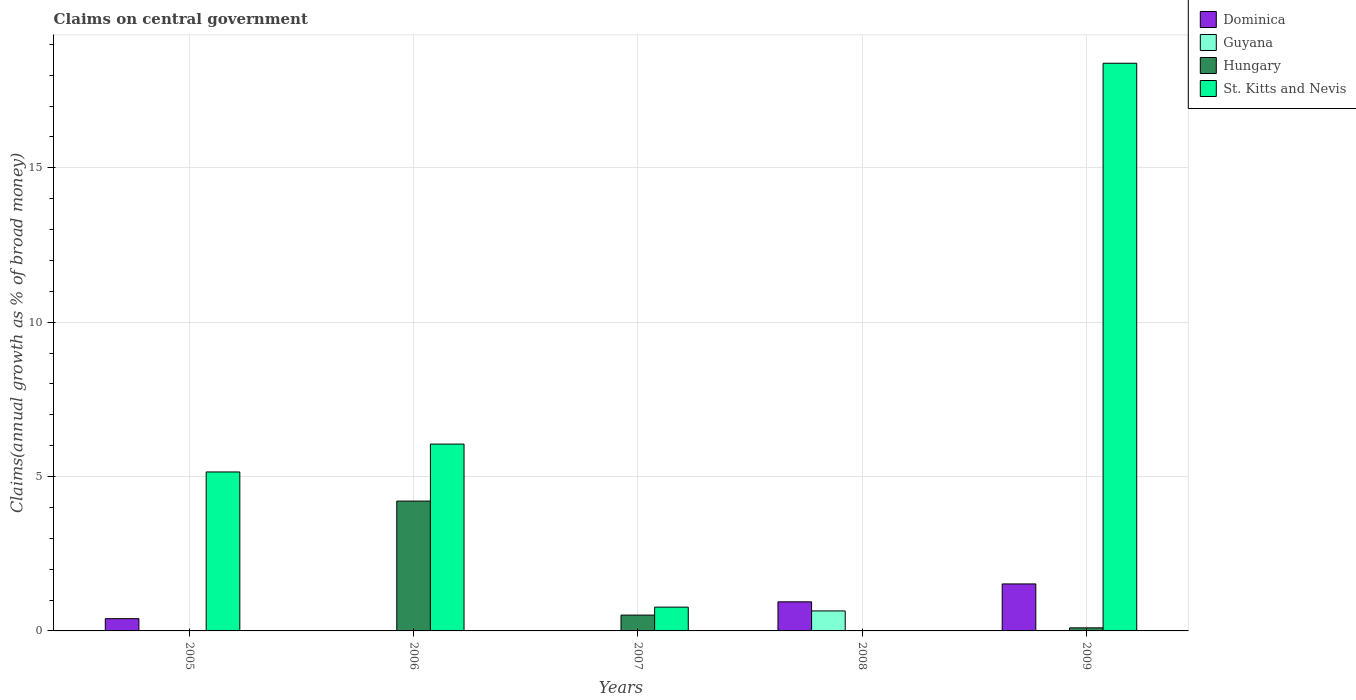How many different coloured bars are there?
Provide a short and direct response. 4. How many groups of bars are there?
Offer a very short reply. 5. Are the number of bars on each tick of the X-axis equal?
Keep it short and to the point. No. How many bars are there on the 4th tick from the left?
Make the answer very short. 2. How many bars are there on the 4th tick from the right?
Make the answer very short. 2. In how many cases, is the number of bars for a given year not equal to the number of legend labels?
Offer a very short reply. 5. What is the percentage of broad money claimed on centeral government in Hungary in 2007?
Keep it short and to the point. 0.51. Across all years, what is the maximum percentage of broad money claimed on centeral government in Guyana?
Provide a short and direct response. 0.65. In which year was the percentage of broad money claimed on centeral government in Hungary maximum?
Provide a short and direct response. 2006. What is the total percentage of broad money claimed on centeral government in Guyana in the graph?
Provide a succinct answer. 0.65. What is the difference between the percentage of broad money claimed on centeral government in St. Kitts and Nevis in 2006 and that in 2007?
Offer a very short reply. 5.28. What is the difference between the percentage of broad money claimed on centeral government in Dominica in 2005 and the percentage of broad money claimed on centeral government in St. Kitts and Nevis in 2006?
Your answer should be very brief. -5.65. What is the average percentage of broad money claimed on centeral government in Guyana per year?
Your answer should be compact. 0.13. In the year 2009, what is the difference between the percentage of broad money claimed on centeral government in Dominica and percentage of broad money claimed on centeral government in Hungary?
Provide a succinct answer. 1.42. What is the ratio of the percentage of broad money claimed on centeral government in St. Kitts and Nevis in 2005 to that in 2007?
Provide a succinct answer. 6.68. What is the difference between the highest and the second highest percentage of broad money claimed on centeral government in St. Kitts and Nevis?
Offer a very short reply. 12.33. What is the difference between the highest and the lowest percentage of broad money claimed on centeral government in Hungary?
Provide a short and direct response. 4.21. Is the sum of the percentage of broad money claimed on centeral government in Hungary in 2007 and 2009 greater than the maximum percentage of broad money claimed on centeral government in Guyana across all years?
Give a very brief answer. No. How many bars are there?
Provide a succinct answer. 11. Are all the bars in the graph horizontal?
Provide a short and direct response. No. How many years are there in the graph?
Make the answer very short. 5. Does the graph contain any zero values?
Provide a succinct answer. Yes. Where does the legend appear in the graph?
Make the answer very short. Top right. How many legend labels are there?
Ensure brevity in your answer.  4. How are the legend labels stacked?
Keep it short and to the point. Vertical. What is the title of the graph?
Provide a short and direct response. Claims on central government. What is the label or title of the Y-axis?
Give a very brief answer. Claims(annual growth as % of broad money). What is the Claims(annual growth as % of broad money) in Dominica in 2005?
Ensure brevity in your answer.  0.4. What is the Claims(annual growth as % of broad money) of St. Kitts and Nevis in 2005?
Make the answer very short. 5.15. What is the Claims(annual growth as % of broad money) of Hungary in 2006?
Offer a very short reply. 4.21. What is the Claims(annual growth as % of broad money) in St. Kitts and Nevis in 2006?
Make the answer very short. 6.05. What is the Claims(annual growth as % of broad money) in Dominica in 2007?
Your answer should be very brief. 0. What is the Claims(annual growth as % of broad money) in Hungary in 2007?
Your answer should be very brief. 0.51. What is the Claims(annual growth as % of broad money) in St. Kitts and Nevis in 2007?
Provide a succinct answer. 0.77. What is the Claims(annual growth as % of broad money) in Dominica in 2008?
Keep it short and to the point. 0.94. What is the Claims(annual growth as % of broad money) of Guyana in 2008?
Offer a terse response. 0.65. What is the Claims(annual growth as % of broad money) of Hungary in 2008?
Your answer should be very brief. 0. What is the Claims(annual growth as % of broad money) of St. Kitts and Nevis in 2008?
Your answer should be compact. 0. What is the Claims(annual growth as % of broad money) in Dominica in 2009?
Provide a succinct answer. 1.52. What is the Claims(annual growth as % of broad money) of Guyana in 2009?
Your answer should be very brief. 0. What is the Claims(annual growth as % of broad money) in Hungary in 2009?
Make the answer very short. 0.1. What is the Claims(annual growth as % of broad money) of St. Kitts and Nevis in 2009?
Keep it short and to the point. 18.39. Across all years, what is the maximum Claims(annual growth as % of broad money) in Dominica?
Give a very brief answer. 1.52. Across all years, what is the maximum Claims(annual growth as % of broad money) in Guyana?
Offer a terse response. 0.65. Across all years, what is the maximum Claims(annual growth as % of broad money) in Hungary?
Your response must be concise. 4.21. Across all years, what is the maximum Claims(annual growth as % of broad money) in St. Kitts and Nevis?
Make the answer very short. 18.39. Across all years, what is the minimum Claims(annual growth as % of broad money) in Guyana?
Keep it short and to the point. 0. Across all years, what is the minimum Claims(annual growth as % of broad money) of Hungary?
Keep it short and to the point. 0. Across all years, what is the minimum Claims(annual growth as % of broad money) in St. Kitts and Nevis?
Offer a very short reply. 0. What is the total Claims(annual growth as % of broad money) in Dominica in the graph?
Make the answer very short. 2.86. What is the total Claims(annual growth as % of broad money) of Guyana in the graph?
Keep it short and to the point. 0.65. What is the total Claims(annual growth as % of broad money) in Hungary in the graph?
Provide a succinct answer. 4.82. What is the total Claims(annual growth as % of broad money) of St. Kitts and Nevis in the graph?
Your response must be concise. 30.36. What is the difference between the Claims(annual growth as % of broad money) in St. Kitts and Nevis in 2005 and that in 2006?
Provide a succinct answer. -0.9. What is the difference between the Claims(annual growth as % of broad money) in St. Kitts and Nevis in 2005 and that in 2007?
Offer a terse response. 4.38. What is the difference between the Claims(annual growth as % of broad money) in Dominica in 2005 and that in 2008?
Your answer should be very brief. -0.55. What is the difference between the Claims(annual growth as % of broad money) of Dominica in 2005 and that in 2009?
Your response must be concise. -1.12. What is the difference between the Claims(annual growth as % of broad money) of St. Kitts and Nevis in 2005 and that in 2009?
Give a very brief answer. -13.24. What is the difference between the Claims(annual growth as % of broad money) in Hungary in 2006 and that in 2007?
Keep it short and to the point. 3.69. What is the difference between the Claims(annual growth as % of broad money) of St. Kitts and Nevis in 2006 and that in 2007?
Offer a terse response. 5.28. What is the difference between the Claims(annual growth as % of broad money) of Hungary in 2006 and that in 2009?
Offer a very short reply. 4.11. What is the difference between the Claims(annual growth as % of broad money) in St. Kitts and Nevis in 2006 and that in 2009?
Keep it short and to the point. -12.33. What is the difference between the Claims(annual growth as % of broad money) of Hungary in 2007 and that in 2009?
Ensure brevity in your answer.  0.41. What is the difference between the Claims(annual growth as % of broad money) in St. Kitts and Nevis in 2007 and that in 2009?
Keep it short and to the point. -17.61. What is the difference between the Claims(annual growth as % of broad money) in Dominica in 2008 and that in 2009?
Your answer should be compact. -0.58. What is the difference between the Claims(annual growth as % of broad money) in Dominica in 2005 and the Claims(annual growth as % of broad money) in Hungary in 2006?
Keep it short and to the point. -3.81. What is the difference between the Claims(annual growth as % of broad money) in Dominica in 2005 and the Claims(annual growth as % of broad money) in St. Kitts and Nevis in 2006?
Offer a very short reply. -5.65. What is the difference between the Claims(annual growth as % of broad money) of Dominica in 2005 and the Claims(annual growth as % of broad money) of Hungary in 2007?
Your answer should be compact. -0.12. What is the difference between the Claims(annual growth as % of broad money) in Dominica in 2005 and the Claims(annual growth as % of broad money) in St. Kitts and Nevis in 2007?
Give a very brief answer. -0.37. What is the difference between the Claims(annual growth as % of broad money) in Dominica in 2005 and the Claims(annual growth as % of broad money) in Guyana in 2008?
Your answer should be compact. -0.25. What is the difference between the Claims(annual growth as % of broad money) of Dominica in 2005 and the Claims(annual growth as % of broad money) of Hungary in 2009?
Ensure brevity in your answer.  0.3. What is the difference between the Claims(annual growth as % of broad money) in Dominica in 2005 and the Claims(annual growth as % of broad money) in St. Kitts and Nevis in 2009?
Offer a terse response. -17.99. What is the difference between the Claims(annual growth as % of broad money) in Hungary in 2006 and the Claims(annual growth as % of broad money) in St. Kitts and Nevis in 2007?
Give a very brief answer. 3.43. What is the difference between the Claims(annual growth as % of broad money) of Hungary in 2006 and the Claims(annual growth as % of broad money) of St. Kitts and Nevis in 2009?
Ensure brevity in your answer.  -14.18. What is the difference between the Claims(annual growth as % of broad money) in Hungary in 2007 and the Claims(annual growth as % of broad money) in St. Kitts and Nevis in 2009?
Offer a very short reply. -17.87. What is the difference between the Claims(annual growth as % of broad money) in Dominica in 2008 and the Claims(annual growth as % of broad money) in Hungary in 2009?
Provide a succinct answer. 0.84. What is the difference between the Claims(annual growth as % of broad money) of Dominica in 2008 and the Claims(annual growth as % of broad money) of St. Kitts and Nevis in 2009?
Provide a succinct answer. -17.44. What is the difference between the Claims(annual growth as % of broad money) of Guyana in 2008 and the Claims(annual growth as % of broad money) of Hungary in 2009?
Ensure brevity in your answer.  0.55. What is the difference between the Claims(annual growth as % of broad money) in Guyana in 2008 and the Claims(annual growth as % of broad money) in St. Kitts and Nevis in 2009?
Your answer should be compact. -17.74. What is the average Claims(annual growth as % of broad money) in Dominica per year?
Provide a short and direct response. 0.57. What is the average Claims(annual growth as % of broad money) in Guyana per year?
Provide a succinct answer. 0.13. What is the average Claims(annual growth as % of broad money) of Hungary per year?
Ensure brevity in your answer.  0.96. What is the average Claims(annual growth as % of broad money) of St. Kitts and Nevis per year?
Offer a very short reply. 6.07. In the year 2005, what is the difference between the Claims(annual growth as % of broad money) in Dominica and Claims(annual growth as % of broad money) in St. Kitts and Nevis?
Your answer should be very brief. -4.75. In the year 2006, what is the difference between the Claims(annual growth as % of broad money) of Hungary and Claims(annual growth as % of broad money) of St. Kitts and Nevis?
Your response must be concise. -1.85. In the year 2007, what is the difference between the Claims(annual growth as % of broad money) in Hungary and Claims(annual growth as % of broad money) in St. Kitts and Nevis?
Offer a very short reply. -0.26. In the year 2008, what is the difference between the Claims(annual growth as % of broad money) of Dominica and Claims(annual growth as % of broad money) of Guyana?
Offer a terse response. 0.29. In the year 2009, what is the difference between the Claims(annual growth as % of broad money) in Dominica and Claims(annual growth as % of broad money) in Hungary?
Provide a short and direct response. 1.42. In the year 2009, what is the difference between the Claims(annual growth as % of broad money) in Dominica and Claims(annual growth as % of broad money) in St. Kitts and Nevis?
Make the answer very short. -16.86. In the year 2009, what is the difference between the Claims(annual growth as % of broad money) of Hungary and Claims(annual growth as % of broad money) of St. Kitts and Nevis?
Keep it short and to the point. -18.29. What is the ratio of the Claims(annual growth as % of broad money) in St. Kitts and Nevis in 2005 to that in 2006?
Your answer should be very brief. 0.85. What is the ratio of the Claims(annual growth as % of broad money) of St. Kitts and Nevis in 2005 to that in 2007?
Your response must be concise. 6.68. What is the ratio of the Claims(annual growth as % of broad money) of Dominica in 2005 to that in 2008?
Offer a terse response. 0.42. What is the ratio of the Claims(annual growth as % of broad money) of Dominica in 2005 to that in 2009?
Your answer should be very brief. 0.26. What is the ratio of the Claims(annual growth as % of broad money) in St. Kitts and Nevis in 2005 to that in 2009?
Make the answer very short. 0.28. What is the ratio of the Claims(annual growth as % of broad money) of Hungary in 2006 to that in 2007?
Give a very brief answer. 8.21. What is the ratio of the Claims(annual growth as % of broad money) in St. Kitts and Nevis in 2006 to that in 2007?
Offer a very short reply. 7.85. What is the ratio of the Claims(annual growth as % of broad money) in Hungary in 2006 to that in 2009?
Give a very brief answer. 42.38. What is the ratio of the Claims(annual growth as % of broad money) of St. Kitts and Nevis in 2006 to that in 2009?
Offer a terse response. 0.33. What is the ratio of the Claims(annual growth as % of broad money) of Hungary in 2007 to that in 2009?
Provide a succinct answer. 5.16. What is the ratio of the Claims(annual growth as % of broad money) in St. Kitts and Nevis in 2007 to that in 2009?
Your response must be concise. 0.04. What is the ratio of the Claims(annual growth as % of broad money) of Dominica in 2008 to that in 2009?
Provide a short and direct response. 0.62. What is the difference between the highest and the second highest Claims(annual growth as % of broad money) of Dominica?
Your answer should be compact. 0.58. What is the difference between the highest and the second highest Claims(annual growth as % of broad money) of Hungary?
Provide a succinct answer. 3.69. What is the difference between the highest and the second highest Claims(annual growth as % of broad money) in St. Kitts and Nevis?
Ensure brevity in your answer.  12.33. What is the difference between the highest and the lowest Claims(annual growth as % of broad money) in Dominica?
Ensure brevity in your answer.  1.52. What is the difference between the highest and the lowest Claims(annual growth as % of broad money) of Guyana?
Your response must be concise. 0.65. What is the difference between the highest and the lowest Claims(annual growth as % of broad money) in Hungary?
Make the answer very short. 4.21. What is the difference between the highest and the lowest Claims(annual growth as % of broad money) in St. Kitts and Nevis?
Make the answer very short. 18.39. 